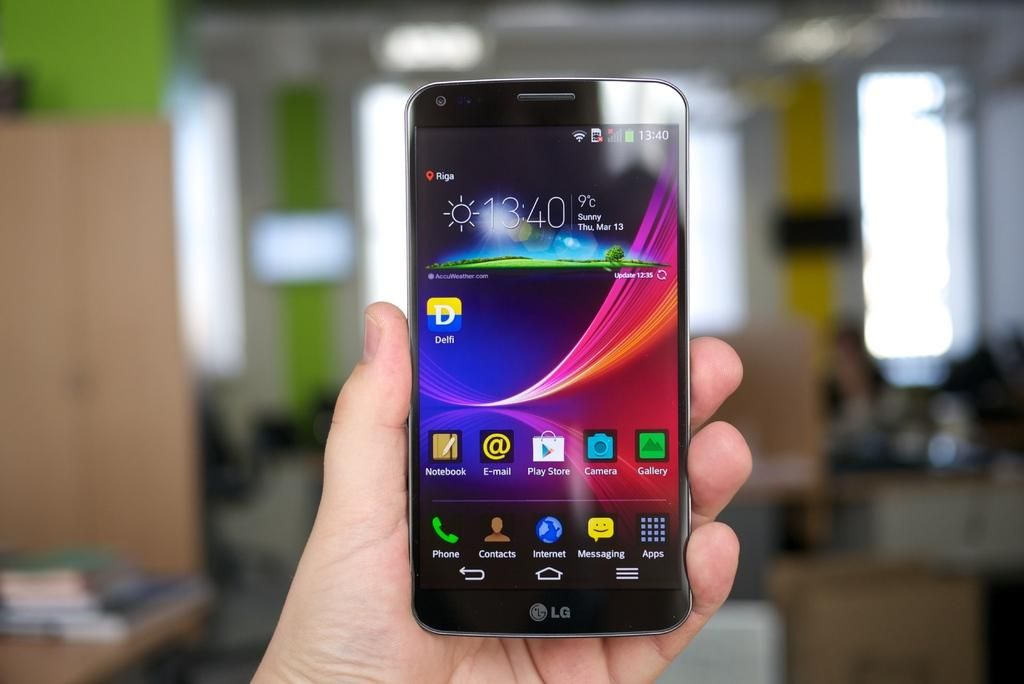What is the main subject in the center of the image? There is a human hand holding a smartphone in the center of the image. What can be seen in the background of the image? There is a wall, a table, books, and a few other objects in the background of the image. Can you describe the table in the background? The table is in the background of the image, and it has books and other objects on it. What type of bird is perched on the smartphone in the image? There is no bird present in the image; it only shows a human hand holding a smartphone. 